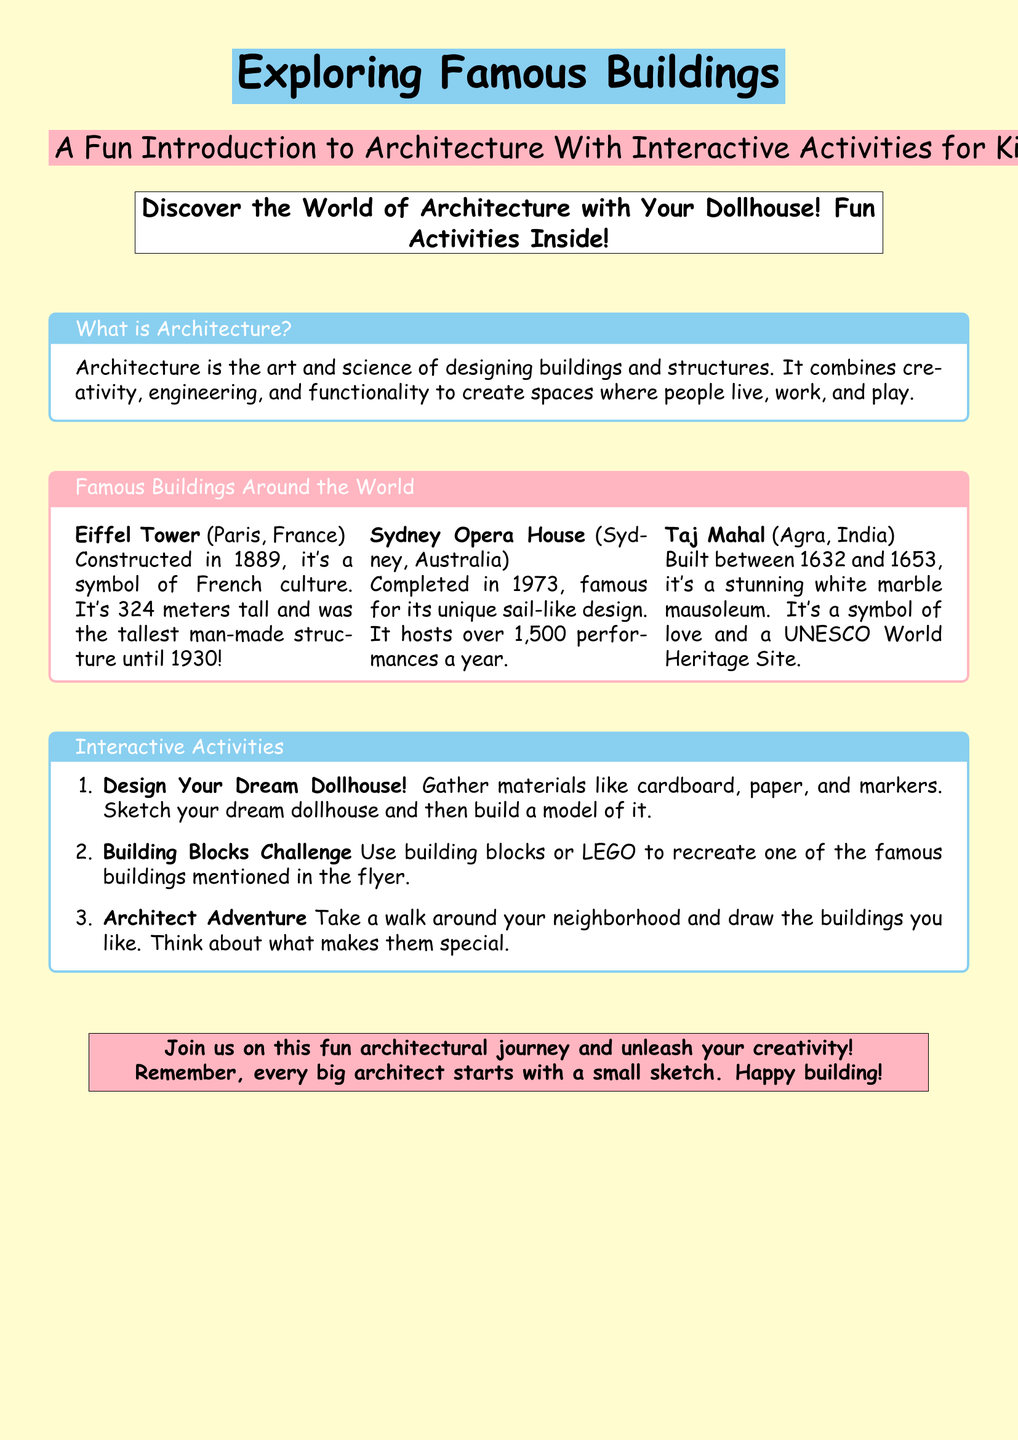what is architecture? Architecture is described as the art and science of designing buildings and structures.
Answer: art and science how tall is the Eiffel Tower? The height of the Eiffel Tower is mentioned to be 324 meters.
Answer: 324 meters when was Sydney Opera House completed? The completion year of Sydney Opera House is provided as 1973.
Answer: 1973 what is the Taj Mahal a symbol of? The document states that the Taj Mahal is a symbol of love.
Answer: love name one interactive activity suggested in the flyer. An activity suggested in the flyer is "Design Your Dream Dollhouse."
Answer: Design Your Dream Dollhouse how many performances does the Sydney Opera House host yearly? The document specifies that over 1,500 performances take place each year at the Sydney Opera House.
Answer: over 1,500 performances what is one material you can use to build your dream dollhouse? The flyer mentions using materials like cardboard, paper, and markers for building the dollhouse.
Answer: cardboard what famous structure was the tallest man-made structure until 1930? The Eiffel Tower is stated as the tallest man-made structure until 1930.
Answer: Eiffel Tower which UNESCO World Heritage Site is mentioned? The Taj Mahal is identified as a UNESCO World Heritage Site in the document.
Answer: Taj Mahal 